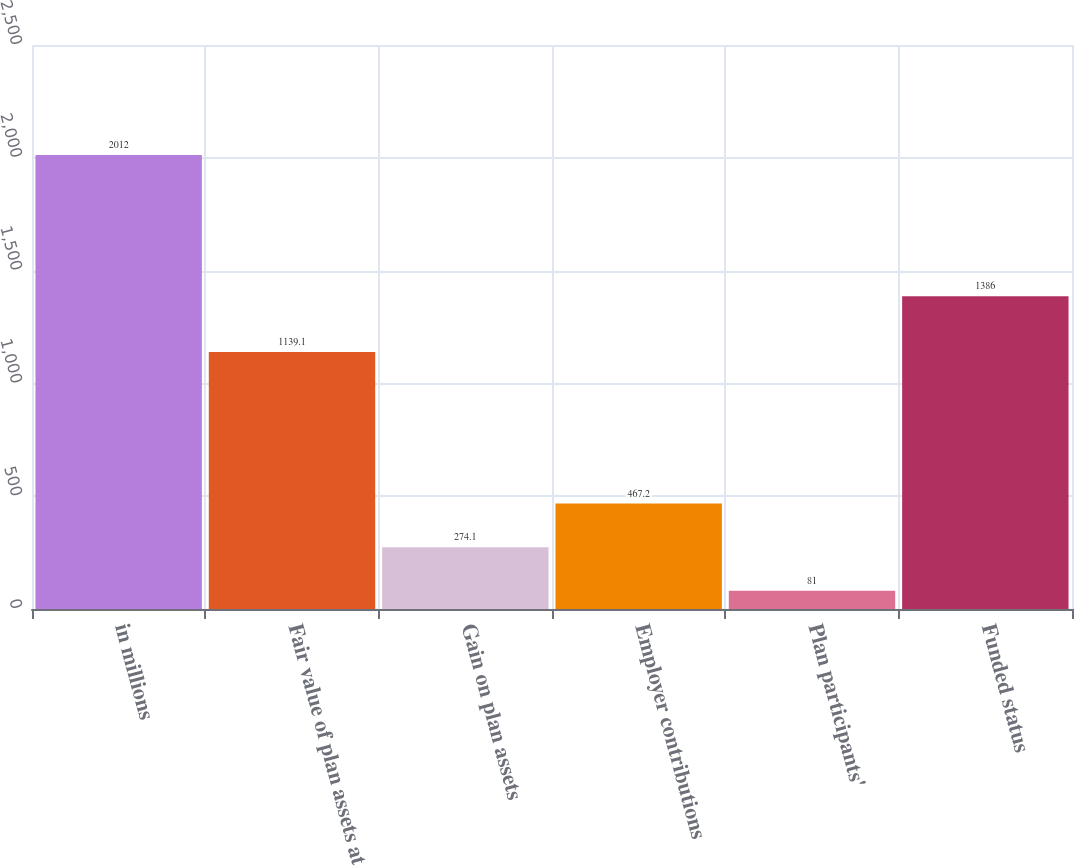<chart> <loc_0><loc_0><loc_500><loc_500><bar_chart><fcel>in millions<fcel>Fair value of plan assets at<fcel>Gain on plan assets<fcel>Employer contributions<fcel>Plan participants'<fcel>Funded status<nl><fcel>2012<fcel>1139.1<fcel>274.1<fcel>467.2<fcel>81<fcel>1386<nl></chart> 